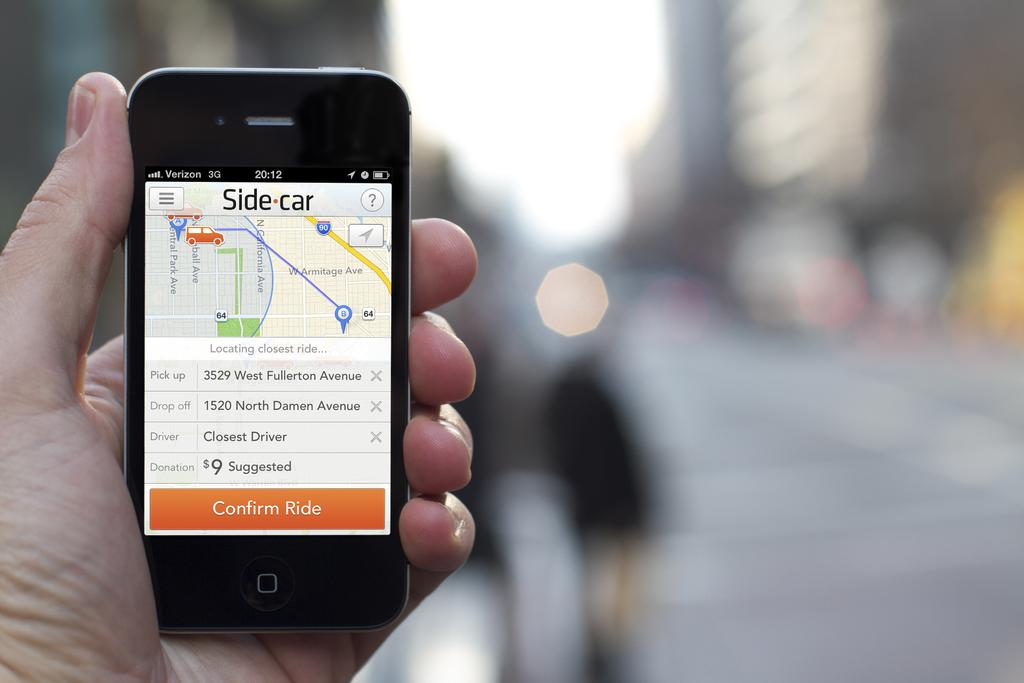<image>
Write a terse but informative summary of the picture. A person is holding up an iPhone that has a map app open called Side car. 